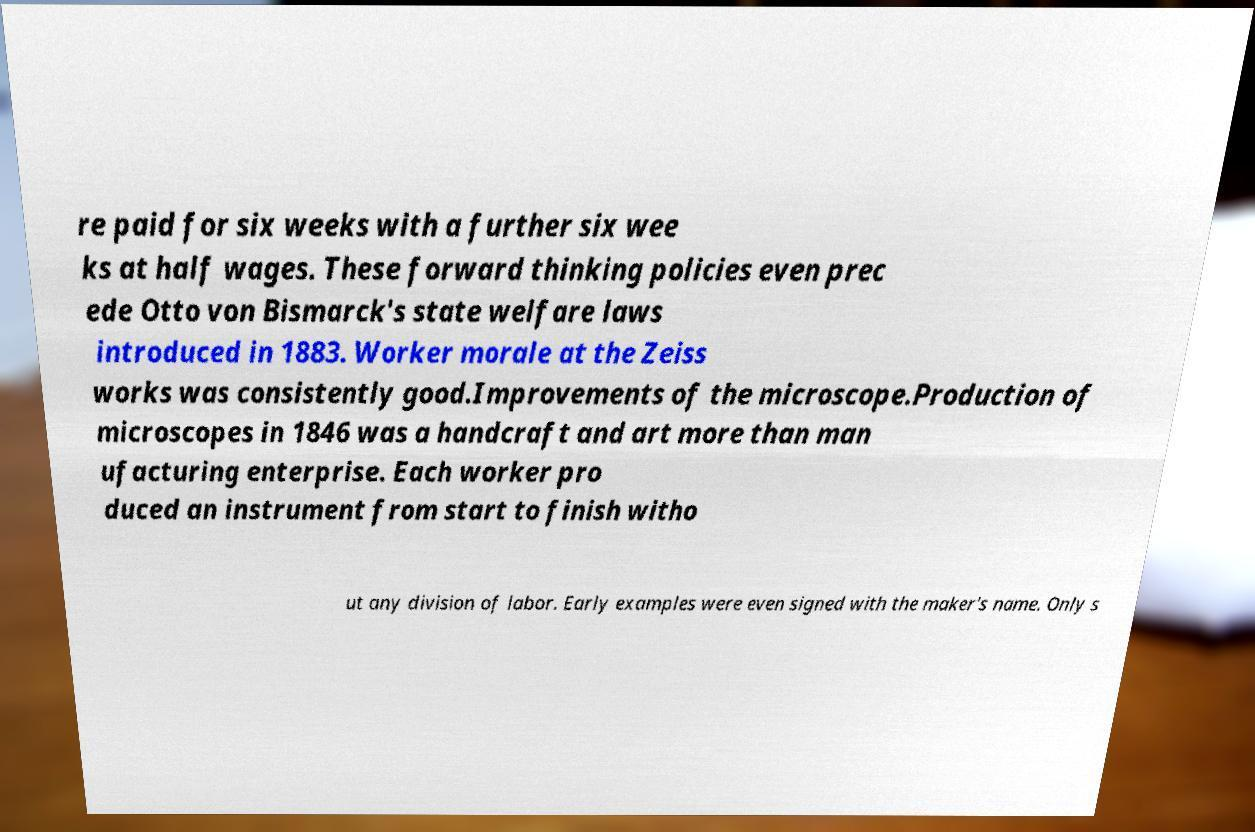For documentation purposes, I need the text within this image transcribed. Could you provide that? re paid for six weeks with a further six wee ks at half wages. These forward thinking policies even prec ede Otto von Bismarck's state welfare laws introduced in 1883. Worker morale at the Zeiss works was consistently good.Improvements of the microscope.Production of microscopes in 1846 was a handcraft and art more than man ufacturing enterprise. Each worker pro duced an instrument from start to finish witho ut any division of labor. Early examples were even signed with the maker's name. Only s 